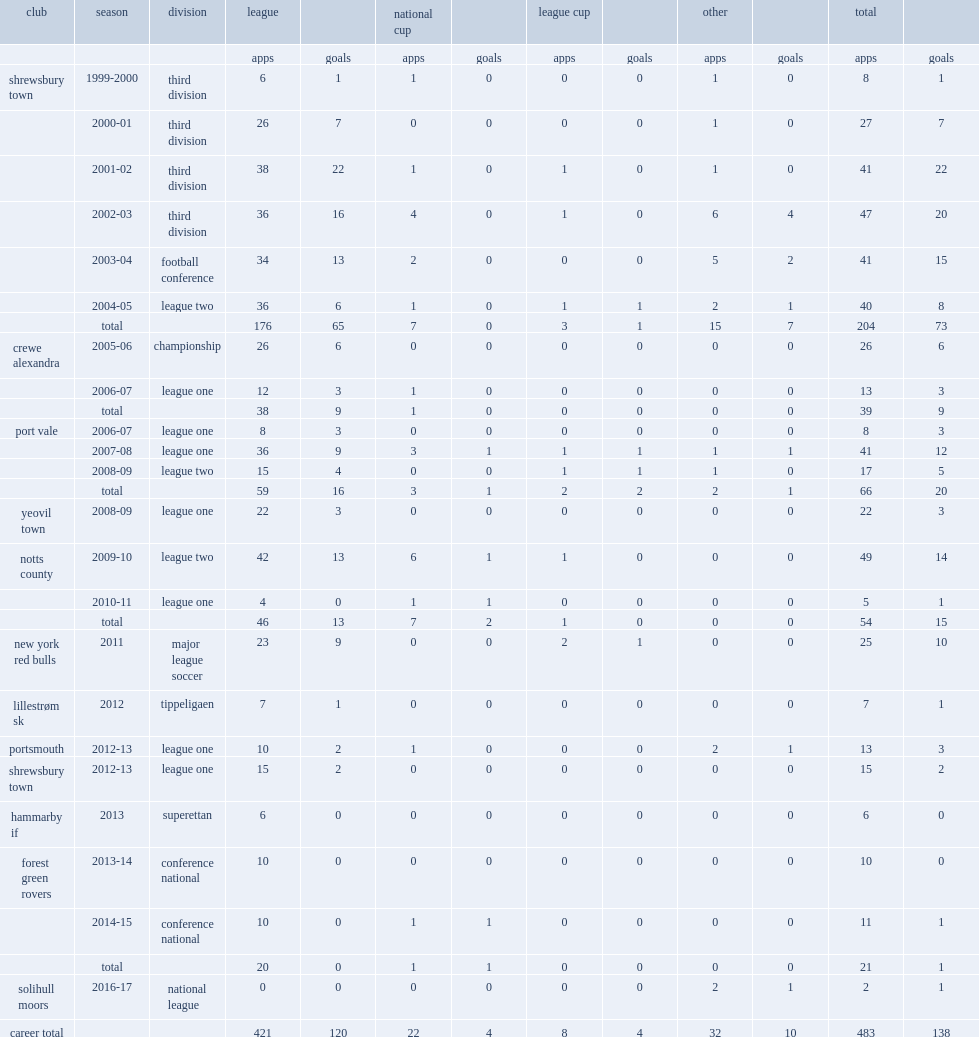Which club did luke rodgers play for in 2011? New york red bulls. Can you give me this table as a dict? {'header': ['club', 'season', 'division', 'league', '', 'national cup', '', 'league cup', '', 'other', '', 'total', ''], 'rows': [['', '', '', 'apps', 'goals', 'apps', 'goals', 'apps', 'goals', 'apps', 'goals', 'apps', 'goals'], ['shrewsbury town', '1999-2000', 'third division', '6', '1', '1', '0', '0', '0', '1', '0', '8', '1'], ['', '2000-01', 'third division', '26', '7', '0', '0', '0', '0', '1', '0', '27', '7'], ['', '2001-02', 'third division', '38', '22', '1', '0', '1', '0', '1', '0', '41', '22'], ['', '2002-03', 'third division', '36', '16', '4', '0', '1', '0', '6', '4', '47', '20'], ['', '2003-04', 'football conference', '34', '13', '2', '0', '0', '0', '5', '2', '41', '15'], ['', '2004-05', 'league two', '36', '6', '1', '0', '1', '1', '2', '1', '40', '8'], ['', 'total', '', '176', '65', '7', '0', '3', '1', '15', '7', '204', '73'], ['crewe alexandra', '2005-06', 'championship', '26', '6', '0', '0', '0', '0', '0', '0', '26', '6'], ['', '2006-07', 'league one', '12', '3', '1', '0', '0', '0', '0', '0', '13', '3'], ['', 'total', '', '38', '9', '1', '0', '0', '0', '0', '0', '39', '9'], ['port vale', '2006-07', 'league one', '8', '3', '0', '0', '0', '0', '0', '0', '8', '3'], ['', '2007-08', 'league one', '36', '9', '3', '1', '1', '1', '1', '1', '41', '12'], ['', '2008-09', 'league two', '15', '4', '0', '0', '1', '1', '1', '0', '17', '5'], ['', 'total', '', '59', '16', '3', '1', '2', '2', '2', '1', '66', '20'], ['yeovil town', '2008-09', 'league one', '22', '3', '0', '0', '0', '0', '0', '0', '22', '3'], ['notts county', '2009-10', 'league two', '42', '13', '6', '1', '1', '0', '0', '0', '49', '14'], ['', '2010-11', 'league one', '4', '0', '1', '1', '0', '0', '0', '0', '5', '1'], ['', 'total', '', '46', '13', '7', '2', '1', '0', '0', '0', '54', '15'], ['new york red bulls', '2011', 'major league soccer', '23', '9', '0', '0', '2', '1', '0', '0', '25', '10'], ['lillestrøm sk', '2012', 'tippeligaen', '7', '1', '0', '0', '0', '0', '0', '0', '7', '1'], ['portsmouth', '2012-13', 'league one', '10', '2', '1', '0', '0', '0', '2', '1', '13', '3'], ['shrewsbury town', '2012-13', 'league one', '15', '2', '0', '0', '0', '0', '0', '0', '15', '2'], ['hammarby if', '2013', 'superettan', '6', '0', '0', '0', '0', '0', '0', '0', '6', '0'], ['forest green rovers', '2013-14', 'conference national', '10', '0', '0', '0', '0', '0', '0', '0', '10', '0'], ['', '2014-15', 'conference national', '10', '0', '1', '1', '0', '0', '0', '0', '11', '1'], ['', 'total', '', '20', '0', '1', '1', '0', '0', '0', '0', '21', '1'], ['solihull moors', '2016-17', 'national league', '0', '0', '0', '0', '0', '0', '2', '1', '2', '1'], ['career total', '', '', '421', '120', '22', '4', '8', '4', '32', '10', '483', '138']]} 